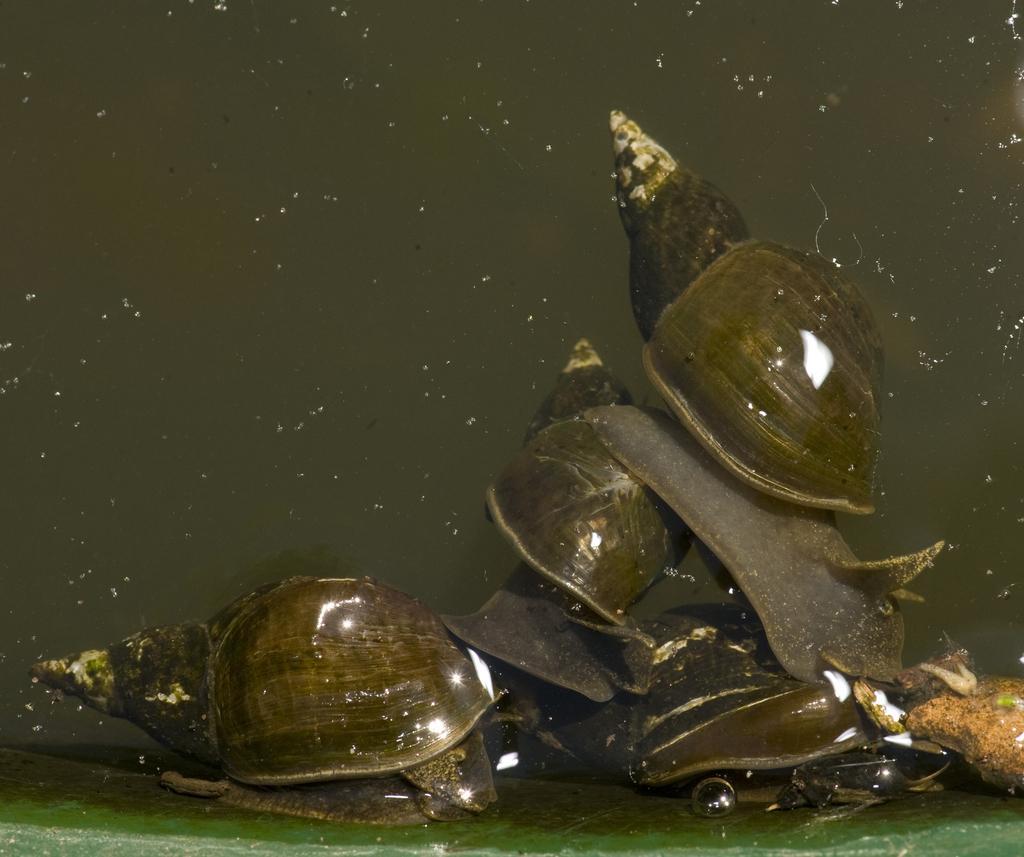Describe this image in one or two sentences. In this image we can see shells. 